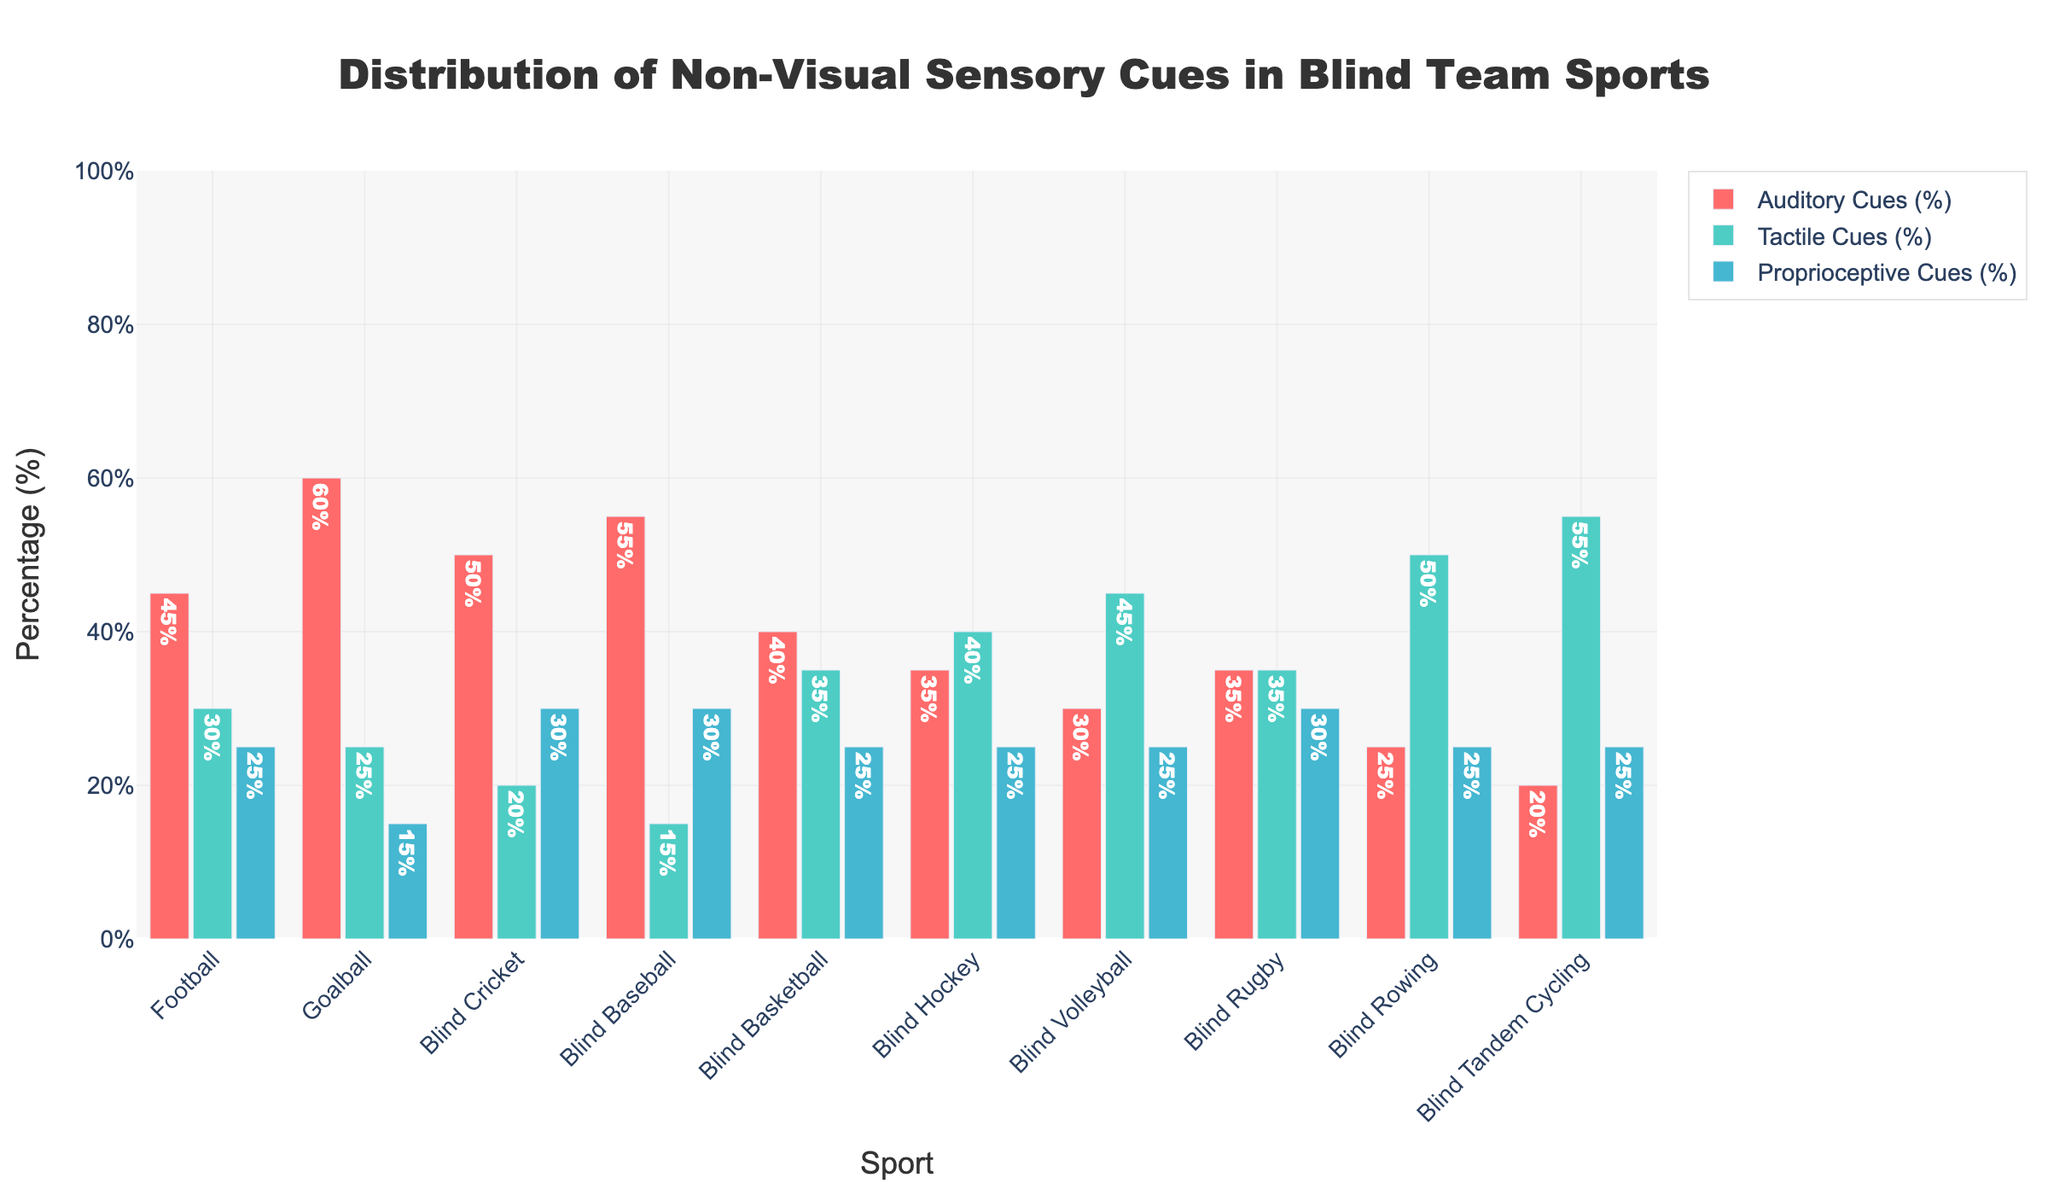What sport relies most heavily on tactile cues? To find the sport that relies most heavily on tactile cues, observe the bar heights representing tactile cues for each sport. Blind Tandem Cycling has the highest bar for tactile cues at 55%.
Answer: Blind Tandem Cycling Which sport has a balanced distribution of all three types of sensory cues? Identify the sport where the bars representing auditory, tactile, and proprioceptive cues are relatively close in height. Blind Rugby shows a balanced distribution with 35% auditory, 35% tactile, and 30% proprioceptive cues.
Answer: Blind Rugby What is the total percentage of auditory cues used in Football and Goalball combined? Add the percentages of auditory cues for both sports: 45% (Football) + 60% (Goalball) = 105%.
Answer: 105% Which type of non-visual sensory cue is least utilized in Blind Baseball? Find the shortest bar representing the different sensory cues for Blind Baseball. The proprioceptive cues bar is at 30%, auditory cues at 55%, and tactile cues at 15%, making tactile cues the least utilized.
Answer: Tactile Cues Among Blind Volleyball and Blind Hockey, which sport relies more on auditory cues? Compare the heights of the auditory cues bars for Blind Volleyball and Blind Hockey. Blind Volleyball has 30% while Blind Hockey has 35%, showing Blind Hockey relies more on auditory cues.
Answer: Blind Hockey What is the average percentage of tactile cues used across all sports? Sum the percentages of tactile cues for each sport and then divide by the number of sports: (30 + 25 + 20 + 15 + 35 + 40 + 45 + 35 + 50 + 55) / 10 = 35%.
Answer: 35% What is the difference in proprioceptive cue usage between Blind Cricket and Blind Rowing? Subtract the percentage of proprioceptive cues in Blind Rowing from Blind Cricket: 30% (Blind Cricket) - 25% (Blind Rowing) = 5%.
Answer: 5% Which sport has the highest combined percentage of tactile and proprioceptive cues? Sum the tactile and proprioceptive cues for each sport and find the maximum: For Blind Tandem Cycling (55+25=80%), others are lower, so Blind Tandem Cycling has the highest combined percentage.
Answer: Blind Tandem Cycling What visual attribute indicates the highest usage of auditory cues in the figure? The bar colored in red indicates auditory cues. Observing the heights, Goalball's red bar is the tallest at 60%.
Answer: Goalball How much more does Blind Basketball rely on proprioceptive cues compared to Blind Football? Subtract the percentage of proprioceptive cues in Blind Football from Blind Basketball: 25% (Blind Basketball) - 25% (Blind Football) = 0%.
Answer: 0% 